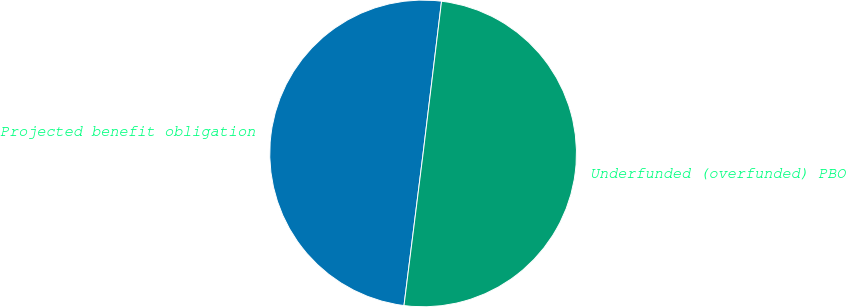Convert chart. <chart><loc_0><loc_0><loc_500><loc_500><pie_chart><fcel>Projected benefit obligation<fcel>Underfunded (overfunded) PBO<nl><fcel>49.93%<fcel>50.07%<nl></chart> 